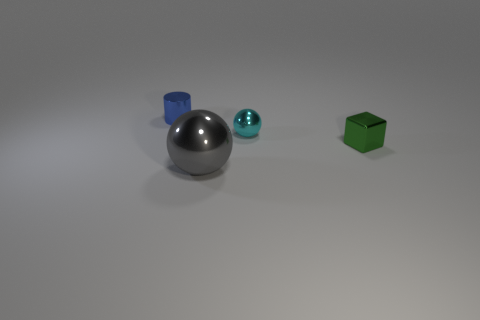If we were to describe this scene in terms of basic geometry, how would you do it? In terms of basic geometry, this scene features a combination of primary 3D shapes. There is a silver sphere, which represents a three-dimensional shape that is perfectly symmetrical along every axis. The cyan object is also a sphere, maintaining the attributes of roundness and symmetry. Lastly, the green object is a cube, characterized by its six equal square faces and twelve equal edges. The placement of these objects can be described as situated on a flat surface with the sphere and cube spaced apart, portraying a simple and clean geometric arrangement. 